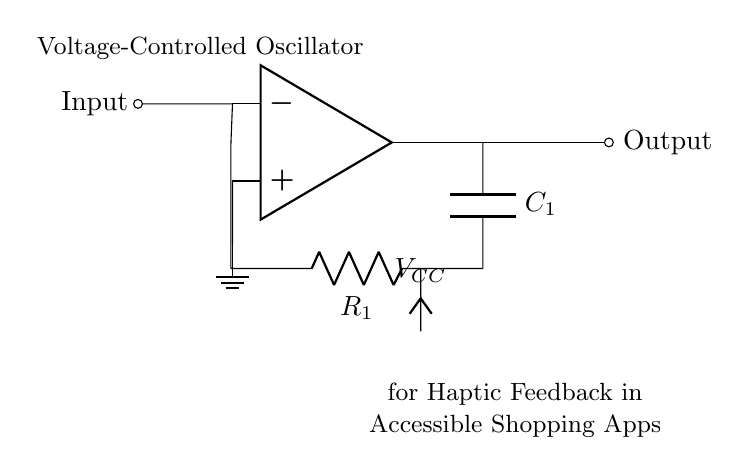What type of oscillator is represented in the circuit? The circuit represents a voltage-controlled oscillator, indicated by the design and labeling in the diagram. Voltage-controlled oscillators are characterized by an input voltage that modifies the oscillation frequency.
Answer: voltage-controlled oscillator What is the role of the capacitor in this circuit? The capacitor is part of the feedback network and helps determine the frequency of the oscillation along with the resistor. It stores and releases charge, which is essential for oscillatory behavior.
Answer: frequency determination What is the output labeled as in the circuit? The output is labeled as "Output" in the diagram, suggesting it is the point where the oscillating signal is taken for further use, such as for haptic feedback.
Answer: Output What components are used in the feedback loop? The feedback loop consists of a resistor and a capacitor. These components interact to influence the timing and stability of the oscillator's output.
Answer: resistor and capacitor How does the voltage control aspect work in this oscillator? The voltage control works by adjusting the input voltage to the op-amp, which alters the charge and discharge rate of the capacitor, thereby changing the oscillation frequency. This relationship allows for customizable haptic feedback based on user input.
Answer: adjusts oscillation frequency 